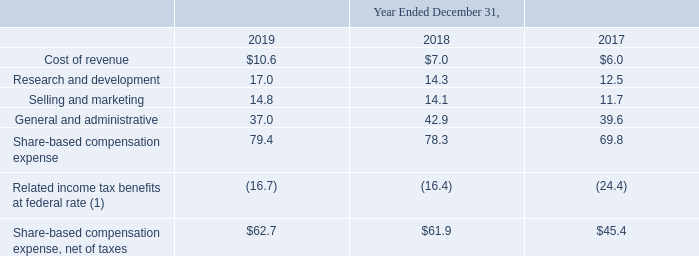Note 11: Share-Based Compensation
Total share-based compensation expense related to the Company's stock options, RSUs, stock grant awards and ESPP were recorded within the Consolidated Statements of Operations and Comprehensive Income as follows (in millions):
(1) Recognition of related income tax benefits are the result of the adoption of ASU 2016-09 during the first quarter of 2017 through a cumulative effect adjustment of $68.1 million recorded as a credit to retained earnings as of January 1, 2017. Tax benefit is calculated using the federal statutory rate of 21% during the years ended December 31, 2019 and December 31, 2018, and 35% for the year ended December 31, 2017.
At December 31, 2019, total unrecognized share-based compensation expense, net of estimated forfeitures, related to non-vested RSUs with service, performance and market conditions was $74.9 million, which is expected to be recognized over a weighted-average period of 1.3 years. The total intrinsic value of stock options exercised during the year ended December 31, 2019 was $3.9 million.
The Company received cash of $1.7 million and $26.2 million from the exercise of stock options and the issuance of shares under the ESPP, respectively. Upon option exercise, vesting of RSUs, stock grant awards, or completion of a purchase under the ESPP, the Company issues new shares of common stock.
How much was the total intrinsic value of stock options exercised during the year ended December 31, 2019? $3.9 million. How much cash was recieved from the exercise of stock options and the issuance of shares under the ESPP, respectively? $1.7 million, $26.2 million. What is the cost of revenue in 2019?
Answer scale should be: million. $10.6. What is the change in Cost of revenue from December 31, 2018 to 2019?
Answer scale should be: million. 10.6-7.0
Answer: 3.6. What is the change in Research and development from year ended December 31, 2018 to 2019?
Answer scale should be: million. 17.0-14.3
Answer: 2.7. What is the average Cost of revenue for December 31, 2018 and 2019?
Answer scale should be: million. (10.6+7.0) / 2
Answer: 8.8. 